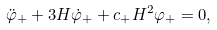<formula> <loc_0><loc_0><loc_500><loc_500>\ddot { \varphi } _ { + } + 3 H \dot { \varphi } _ { + } + c _ { + } H ^ { 2 } \varphi _ { + } = 0 ,</formula> 